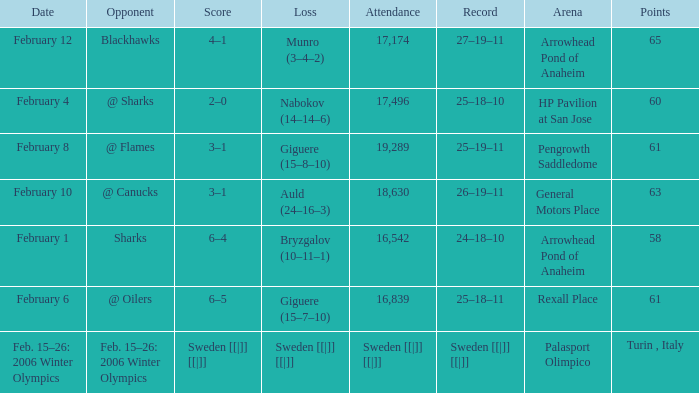What is the record at Arrowhead Pond of Anaheim, when the loss was Bryzgalov (10–11–1)? 24–18–10. 